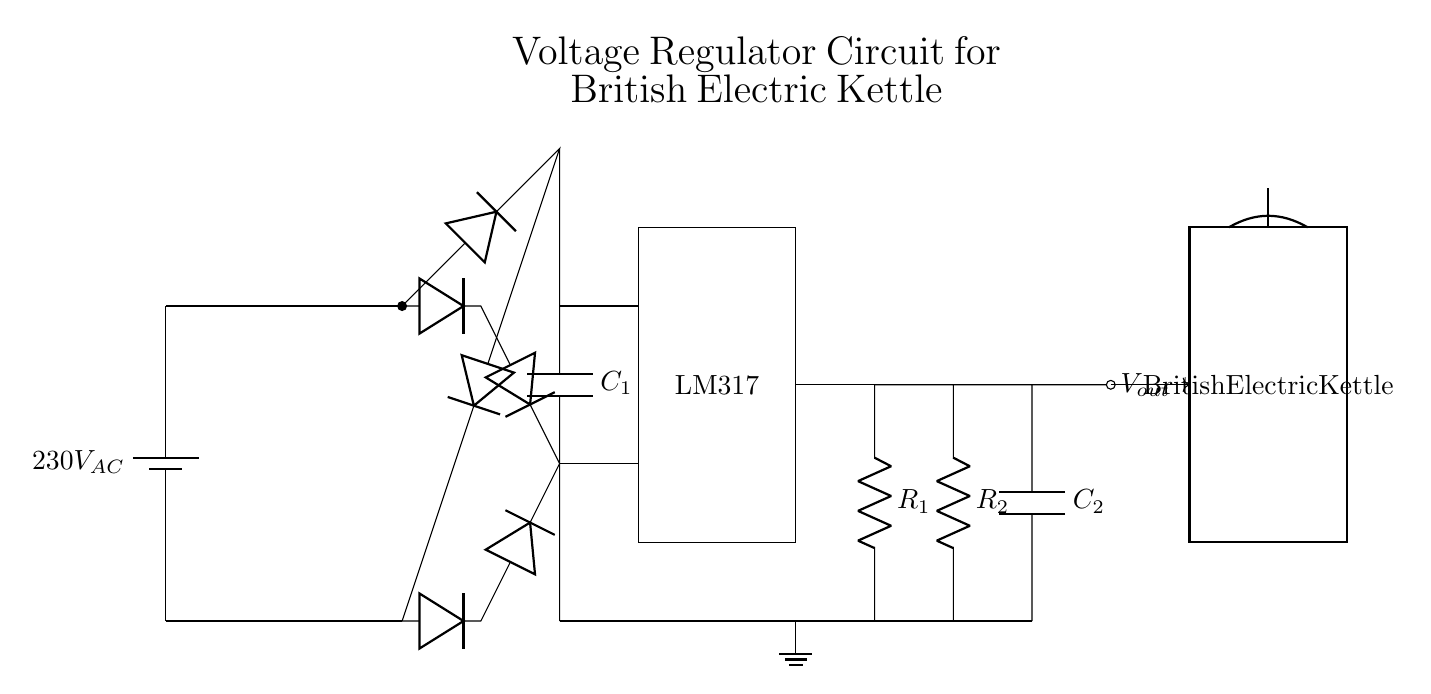What is the AC voltage supplied to the circuit? The circuit diagram shows a battery symbol labeled with 230V AC, indicating that this is the alternating current voltage supplied to the circuit.
Answer: 230V AC What component converts AC to DC in this circuit? The transformer takes the 230V AC voltage and steps it down, then the diodes in the bridge rectifier convert the AC to DC. Together, they perform the AC to DC conversion.
Answer: Bridge rectifier What type of voltage regulator is used in the circuit? The LM317 is depicted as a rectangle with its name inside, clearly indicating it is the type of voltage regulator used in this specific circuit.
Answer: LM317 What is the purpose of the capacitor labeled C1? C1 is connected in parallel with the rectifier output, serving as a smoothing capacitor to reduce voltage fluctuations and provide a more stable DC voltage to the circuit.
Answer: Smoothing How does the output voltage relate to the resistor values R1 and R2? The output voltage is adjusted based on the resistor values according to the formula for the LM317, which relates the output voltage to the ratio of R1 and R2. Thus, changing the resistor values alters the output voltage level.
Answer: Adjustable What is the role of the capacitor labeled C2 in this circuit? C2 is connected at the output of the LM317, which helps to stabilize the output voltage further by filtering high-frequency noise, improving the quality of the regulated output.
Answer: Stabilization 